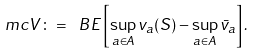Convert formula to latex. <formula><loc_0><loc_0><loc_500><loc_500>\ m c { V } \colon = \ B E \left [ \sup _ { a \in A } v _ { a } ( S ) - \sup _ { a \in A } \bar { v } _ { a } \right ] .</formula> 